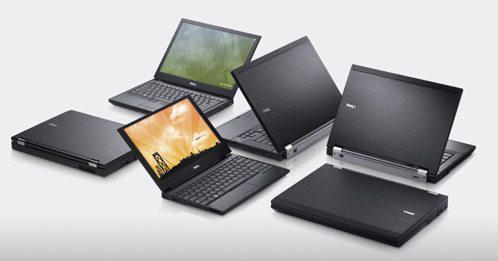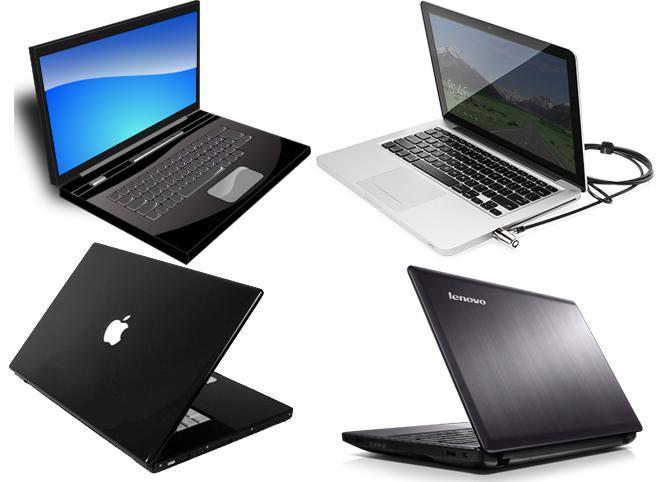The first image is the image on the left, the second image is the image on the right. Given the left and right images, does the statement "The right image contains exactly four laptop computers." hold true? Answer yes or no. Yes. The first image is the image on the left, the second image is the image on the right. Given the left and right images, does the statement "There are more devices in the image on the left than in the image on the right." hold true? Answer yes or no. Yes. 